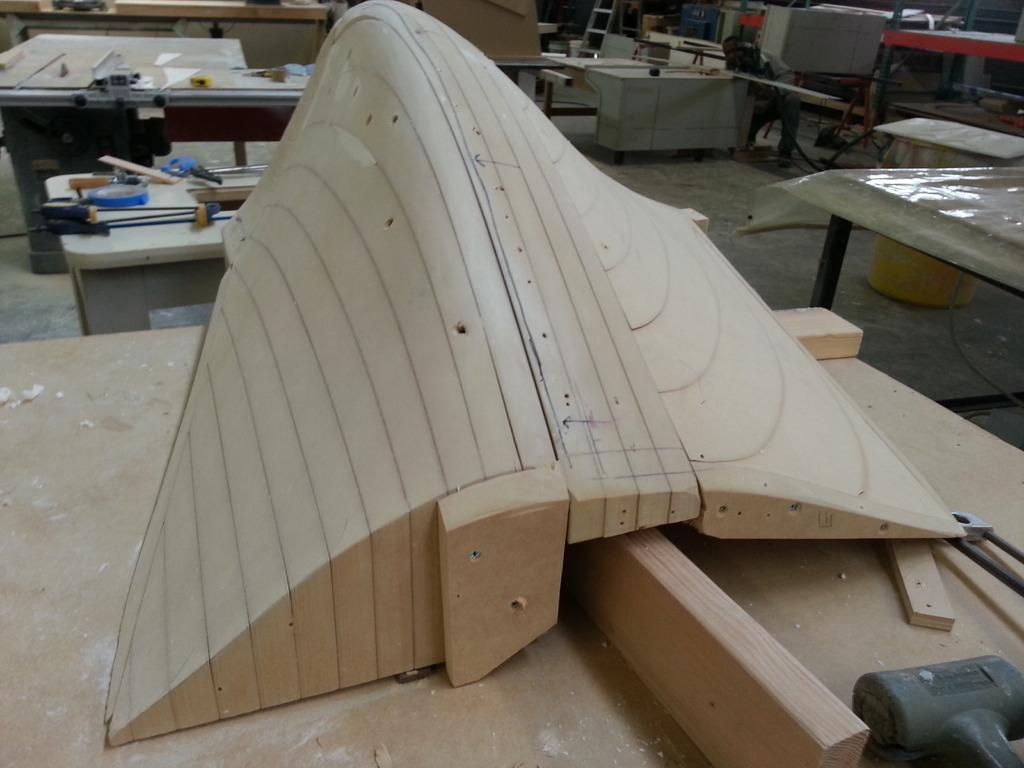What is the main object in the center of the image? There is plywood in the center of the image. What else can be seen on the left side of the image? There are other tools on the left side of the image. How many trees are visible in the image? There are no trees visible in the image; it features plywood and tools. What type of curtain is hanging in the background of the image? There is no curtain present in the image. 